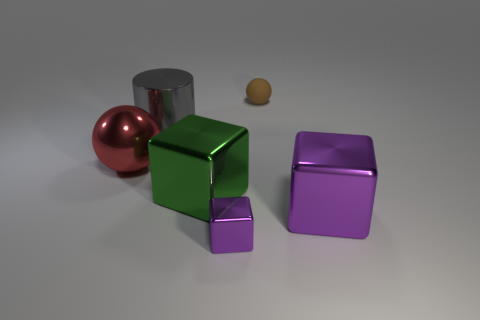Add 1 small purple shiny cubes. How many objects exist? 7 Subtract all purple blocks. How many blocks are left? 1 Subtract all large shiny cubes. How many cubes are left? 1 Subtract all balls. How many objects are left? 4 Subtract 1 cylinders. How many cylinders are left? 0 Subtract all brown spheres. Subtract all yellow blocks. How many spheres are left? 1 Subtract all green cubes. How many yellow cylinders are left? 0 Subtract all large metal objects. Subtract all balls. How many objects are left? 0 Add 1 large red metallic balls. How many large red metallic balls are left? 2 Add 5 big red metallic things. How many big red metallic things exist? 6 